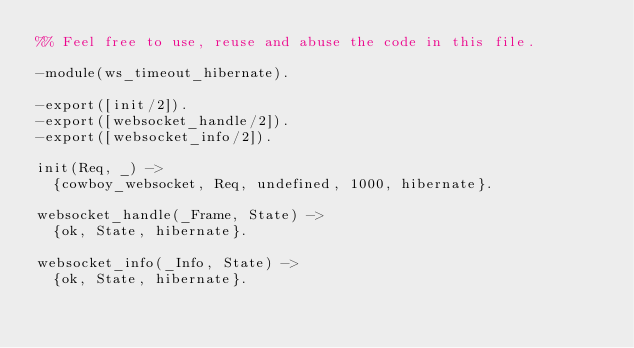Convert code to text. <code><loc_0><loc_0><loc_500><loc_500><_Erlang_>%% Feel free to use, reuse and abuse the code in this file.

-module(ws_timeout_hibernate).

-export([init/2]).
-export([websocket_handle/2]).
-export([websocket_info/2]).

init(Req, _) ->
	{cowboy_websocket, Req, undefined, 1000, hibernate}.

websocket_handle(_Frame, State) ->
	{ok, State, hibernate}.

websocket_info(_Info, State) ->
	{ok, State, hibernate}.
</code> 